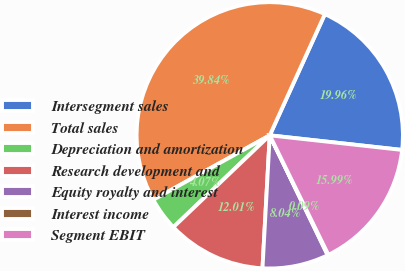<chart> <loc_0><loc_0><loc_500><loc_500><pie_chart><fcel>Intersegment sales<fcel>Total sales<fcel>Depreciation and amortization<fcel>Research development and<fcel>Equity royalty and interest<fcel>Interest income<fcel>Segment EBIT<nl><fcel>19.96%<fcel>39.84%<fcel>4.07%<fcel>12.01%<fcel>8.04%<fcel>0.09%<fcel>15.99%<nl></chart> 